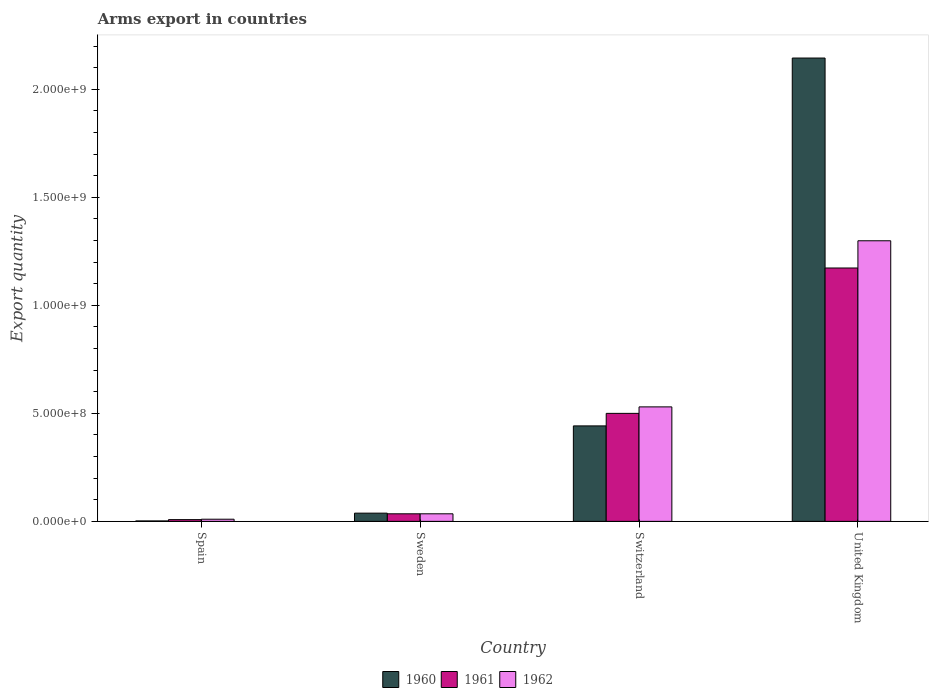How many groups of bars are there?
Your response must be concise. 4. Are the number of bars per tick equal to the number of legend labels?
Give a very brief answer. Yes. Are the number of bars on each tick of the X-axis equal?
Your response must be concise. Yes. In how many cases, is the number of bars for a given country not equal to the number of legend labels?
Offer a terse response. 0. What is the total arms export in 1962 in Spain?
Provide a succinct answer. 1.00e+07. Across all countries, what is the maximum total arms export in 1960?
Give a very brief answer. 2.14e+09. Across all countries, what is the minimum total arms export in 1961?
Give a very brief answer. 8.00e+06. In which country was the total arms export in 1962 minimum?
Make the answer very short. Spain. What is the total total arms export in 1961 in the graph?
Ensure brevity in your answer.  1.72e+09. What is the difference between the total arms export in 1961 in Sweden and that in United Kingdom?
Keep it short and to the point. -1.14e+09. What is the difference between the total arms export in 1962 in Switzerland and the total arms export in 1961 in United Kingdom?
Offer a very short reply. -6.43e+08. What is the average total arms export in 1961 per country?
Keep it short and to the point. 4.29e+08. In how many countries, is the total arms export in 1961 greater than 1600000000?
Offer a very short reply. 0. What is the ratio of the total arms export in 1961 in Spain to that in United Kingdom?
Your answer should be very brief. 0.01. Is the total arms export in 1962 in Switzerland less than that in United Kingdom?
Give a very brief answer. Yes. What is the difference between the highest and the second highest total arms export in 1961?
Your answer should be compact. 6.73e+08. What is the difference between the highest and the lowest total arms export in 1962?
Offer a terse response. 1.29e+09. In how many countries, is the total arms export in 1960 greater than the average total arms export in 1960 taken over all countries?
Provide a short and direct response. 1. What does the 2nd bar from the right in United Kingdom represents?
Your response must be concise. 1961. How many bars are there?
Keep it short and to the point. 12. How many countries are there in the graph?
Give a very brief answer. 4. What is the difference between two consecutive major ticks on the Y-axis?
Give a very brief answer. 5.00e+08. Does the graph contain any zero values?
Make the answer very short. No. Does the graph contain grids?
Your answer should be very brief. No. How many legend labels are there?
Keep it short and to the point. 3. What is the title of the graph?
Provide a succinct answer. Arms export in countries. Does "1966" appear as one of the legend labels in the graph?
Ensure brevity in your answer.  No. What is the label or title of the Y-axis?
Provide a short and direct response. Export quantity. What is the Export quantity of 1960 in Spain?
Make the answer very short. 2.00e+06. What is the Export quantity in 1961 in Spain?
Your answer should be very brief. 8.00e+06. What is the Export quantity of 1962 in Spain?
Your response must be concise. 1.00e+07. What is the Export quantity of 1960 in Sweden?
Ensure brevity in your answer.  3.80e+07. What is the Export quantity in 1961 in Sweden?
Your answer should be very brief. 3.50e+07. What is the Export quantity of 1962 in Sweden?
Your answer should be very brief. 3.50e+07. What is the Export quantity in 1960 in Switzerland?
Provide a short and direct response. 4.42e+08. What is the Export quantity in 1961 in Switzerland?
Provide a short and direct response. 5.00e+08. What is the Export quantity of 1962 in Switzerland?
Ensure brevity in your answer.  5.30e+08. What is the Export quantity in 1960 in United Kingdom?
Ensure brevity in your answer.  2.14e+09. What is the Export quantity in 1961 in United Kingdom?
Offer a terse response. 1.17e+09. What is the Export quantity of 1962 in United Kingdom?
Ensure brevity in your answer.  1.30e+09. Across all countries, what is the maximum Export quantity in 1960?
Make the answer very short. 2.14e+09. Across all countries, what is the maximum Export quantity in 1961?
Offer a terse response. 1.17e+09. Across all countries, what is the maximum Export quantity of 1962?
Your answer should be very brief. 1.30e+09. Across all countries, what is the minimum Export quantity of 1961?
Ensure brevity in your answer.  8.00e+06. Across all countries, what is the minimum Export quantity of 1962?
Your answer should be very brief. 1.00e+07. What is the total Export quantity in 1960 in the graph?
Provide a succinct answer. 2.63e+09. What is the total Export quantity of 1961 in the graph?
Offer a very short reply. 1.72e+09. What is the total Export quantity of 1962 in the graph?
Keep it short and to the point. 1.87e+09. What is the difference between the Export quantity in 1960 in Spain and that in Sweden?
Your response must be concise. -3.60e+07. What is the difference between the Export quantity in 1961 in Spain and that in Sweden?
Give a very brief answer. -2.70e+07. What is the difference between the Export quantity of 1962 in Spain and that in Sweden?
Offer a terse response. -2.50e+07. What is the difference between the Export quantity in 1960 in Spain and that in Switzerland?
Keep it short and to the point. -4.40e+08. What is the difference between the Export quantity of 1961 in Spain and that in Switzerland?
Keep it short and to the point. -4.92e+08. What is the difference between the Export quantity in 1962 in Spain and that in Switzerland?
Provide a succinct answer. -5.20e+08. What is the difference between the Export quantity in 1960 in Spain and that in United Kingdom?
Your answer should be very brief. -2.14e+09. What is the difference between the Export quantity in 1961 in Spain and that in United Kingdom?
Offer a very short reply. -1.16e+09. What is the difference between the Export quantity in 1962 in Spain and that in United Kingdom?
Keep it short and to the point. -1.29e+09. What is the difference between the Export quantity in 1960 in Sweden and that in Switzerland?
Keep it short and to the point. -4.04e+08. What is the difference between the Export quantity in 1961 in Sweden and that in Switzerland?
Offer a very short reply. -4.65e+08. What is the difference between the Export quantity in 1962 in Sweden and that in Switzerland?
Your answer should be compact. -4.95e+08. What is the difference between the Export quantity of 1960 in Sweden and that in United Kingdom?
Your answer should be very brief. -2.11e+09. What is the difference between the Export quantity of 1961 in Sweden and that in United Kingdom?
Provide a succinct answer. -1.14e+09. What is the difference between the Export quantity of 1962 in Sweden and that in United Kingdom?
Your response must be concise. -1.26e+09. What is the difference between the Export quantity of 1960 in Switzerland and that in United Kingdom?
Provide a succinct answer. -1.70e+09. What is the difference between the Export quantity in 1961 in Switzerland and that in United Kingdom?
Make the answer very short. -6.73e+08. What is the difference between the Export quantity of 1962 in Switzerland and that in United Kingdom?
Ensure brevity in your answer.  -7.69e+08. What is the difference between the Export quantity of 1960 in Spain and the Export quantity of 1961 in Sweden?
Offer a very short reply. -3.30e+07. What is the difference between the Export quantity in 1960 in Spain and the Export quantity in 1962 in Sweden?
Offer a terse response. -3.30e+07. What is the difference between the Export quantity in 1961 in Spain and the Export quantity in 1962 in Sweden?
Offer a terse response. -2.70e+07. What is the difference between the Export quantity in 1960 in Spain and the Export quantity in 1961 in Switzerland?
Make the answer very short. -4.98e+08. What is the difference between the Export quantity of 1960 in Spain and the Export quantity of 1962 in Switzerland?
Your answer should be compact. -5.28e+08. What is the difference between the Export quantity of 1961 in Spain and the Export quantity of 1962 in Switzerland?
Ensure brevity in your answer.  -5.22e+08. What is the difference between the Export quantity of 1960 in Spain and the Export quantity of 1961 in United Kingdom?
Your answer should be compact. -1.17e+09. What is the difference between the Export quantity in 1960 in Spain and the Export quantity in 1962 in United Kingdom?
Your answer should be compact. -1.30e+09. What is the difference between the Export quantity of 1961 in Spain and the Export quantity of 1962 in United Kingdom?
Your answer should be compact. -1.29e+09. What is the difference between the Export quantity in 1960 in Sweden and the Export quantity in 1961 in Switzerland?
Offer a terse response. -4.62e+08. What is the difference between the Export quantity of 1960 in Sweden and the Export quantity of 1962 in Switzerland?
Offer a terse response. -4.92e+08. What is the difference between the Export quantity of 1961 in Sweden and the Export quantity of 1962 in Switzerland?
Your answer should be compact. -4.95e+08. What is the difference between the Export quantity in 1960 in Sweden and the Export quantity in 1961 in United Kingdom?
Ensure brevity in your answer.  -1.14e+09. What is the difference between the Export quantity in 1960 in Sweden and the Export quantity in 1962 in United Kingdom?
Your answer should be compact. -1.26e+09. What is the difference between the Export quantity in 1961 in Sweden and the Export quantity in 1962 in United Kingdom?
Your answer should be very brief. -1.26e+09. What is the difference between the Export quantity in 1960 in Switzerland and the Export quantity in 1961 in United Kingdom?
Provide a succinct answer. -7.31e+08. What is the difference between the Export quantity in 1960 in Switzerland and the Export quantity in 1962 in United Kingdom?
Your response must be concise. -8.57e+08. What is the difference between the Export quantity in 1961 in Switzerland and the Export quantity in 1962 in United Kingdom?
Offer a terse response. -7.99e+08. What is the average Export quantity of 1960 per country?
Give a very brief answer. 6.57e+08. What is the average Export quantity of 1961 per country?
Offer a very short reply. 4.29e+08. What is the average Export quantity of 1962 per country?
Offer a very short reply. 4.68e+08. What is the difference between the Export quantity in 1960 and Export quantity in 1961 in Spain?
Your response must be concise. -6.00e+06. What is the difference between the Export quantity of 1960 and Export quantity of 1962 in Spain?
Ensure brevity in your answer.  -8.00e+06. What is the difference between the Export quantity of 1961 and Export quantity of 1962 in Spain?
Your answer should be compact. -2.00e+06. What is the difference between the Export quantity in 1960 and Export quantity in 1961 in Sweden?
Make the answer very short. 3.00e+06. What is the difference between the Export quantity in 1960 and Export quantity in 1962 in Sweden?
Offer a very short reply. 3.00e+06. What is the difference between the Export quantity in 1961 and Export quantity in 1962 in Sweden?
Your response must be concise. 0. What is the difference between the Export quantity of 1960 and Export quantity of 1961 in Switzerland?
Offer a terse response. -5.80e+07. What is the difference between the Export quantity of 1960 and Export quantity of 1962 in Switzerland?
Give a very brief answer. -8.80e+07. What is the difference between the Export quantity of 1961 and Export quantity of 1962 in Switzerland?
Ensure brevity in your answer.  -3.00e+07. What is the difference between the Export quantity in 1960 and Export quantity in 1961 in United Kingdom?
Your answer should be very brief. 9.72e+08. What is the difference between the Export quantity in 1960 and Export quantity in 1962 in United Kingdom?
Your response must be concise. 8.46e+08. What is the difference between the Export quantity in 1961 and Export quantity in 1962 in United Kingdom?
Offer a very short reply. -1.26e+08. What is the ratio of the Export quantity of 1960 in Spain to that in Sweden?
Your answer should be very brief. 0.05. What is the ratio of the Export quantity of 1961 in Spain to that in Sweden?
Offer a terse response. 0.23. What is the ratio of the Export quantity in 1962 in Spain to that in Sweden?
Ensure brevity in your answer.  0.29. What is the ratio of the Export quantity in 1960 in Spain to that in Switzerland?
Keep it short and to the point. 0. What is the ratio of the Export quantity of 1961 in Spain to that in Switzerland?
Provide a succinct answer. 0.02. What is the ratio of the Export quantity of 1962 in Spain to that in Switzerland?
Keep it short and to the point. 0.02. What is the ratio of the Export quantity of 1960 in Spain to that in United Kingdom?
Make the answer very short. 0. What is the ratio of the Export quantity in 1961 in Spain to that in United Kingdom?
Ensure brevity in your answer.  0.01. What is the ratio of the Export quantity of 1962 in Spain to that in United Kingdom?
Provide a short and direct response. 0.01. What is the ratio of the Export quantity in 1960 in Sweden to that in Switzerland?
Your response must be concise. 0.09. What is the ratio of the Export quantity in 1961 in Sweden to that in Switzerland?
Keep it short and to the point. 0.07. What is the ratio of the Export quantity of 1962 in Sweden to that in Switzerland?
Give a very brief answer. 0.07. What is the ratio of the Export quantity in 1960 in Sweden to that in United Kingdom?
Your response must be concise. 0.02. What is the ratio of the Export quantity of 1961 in Sweden to that in United Kingdom?
Give a very brief answer. 0.03. What is the ratio of the Export quantity in 1962 in Sweden to that in United Kingdom?
Your answer should be very brief. 0.03. What is the ratio of the Export quantity of 1960 in Switzerland to that in United Kingdom?
Give a very brief answer. 0.21. What is the ratio of the Export quantity of 1961 in Switzerland to that in United Kingdom?
Provide a short and direct response. 0.43. What is the ratio of the Export quantity of 1962 in Switzerland to that in United Kingdom?
Make the answer very short. 0.41. What is the difference between the highest and the second highest Export quantity of 1960?
Give a very brief answer. 1.70e+09. What is the difference between the highest and the second highest Export quantity in 1961?
Your answer should be compact. 6.73e+08. What is the difference between the highest and the second highest Export quantity of 1962?
Offer a very short reply. 7.69e+08. What is the difference between the highest and the lowest Export quantity in 1960?
Offer a very short reply. 2.14e+09. What is the difference between the highest and the lowest Export quantity of 1961?
Keep it short and to the point. 1.16e+09. What is the difference between the highest and the lowest Export quantity of 1962?
Offer a very short reply. 1.29e+09. 